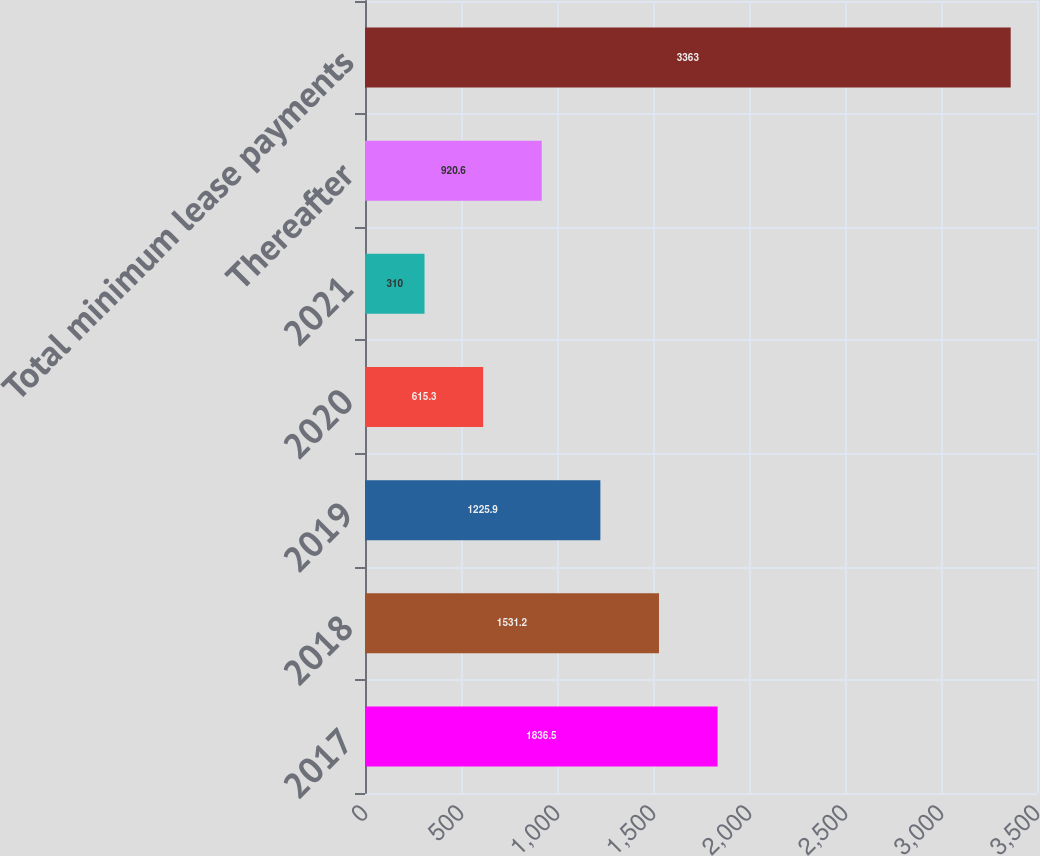<chart> <loc_0><loc_0><loc_500><loc_500><bar_chart><fcel>2017<fcel>2018<fcel>2019<fcel>2020<fcel>2021<fcel>Thereafter<fcel>Total minimum lease payments<nl><fcel>1836.5<fcel>1531.2<fcel>1225.9<fcel>615.3<fcel>310<fcel>920.6<fcel>3363<nl></chart> 